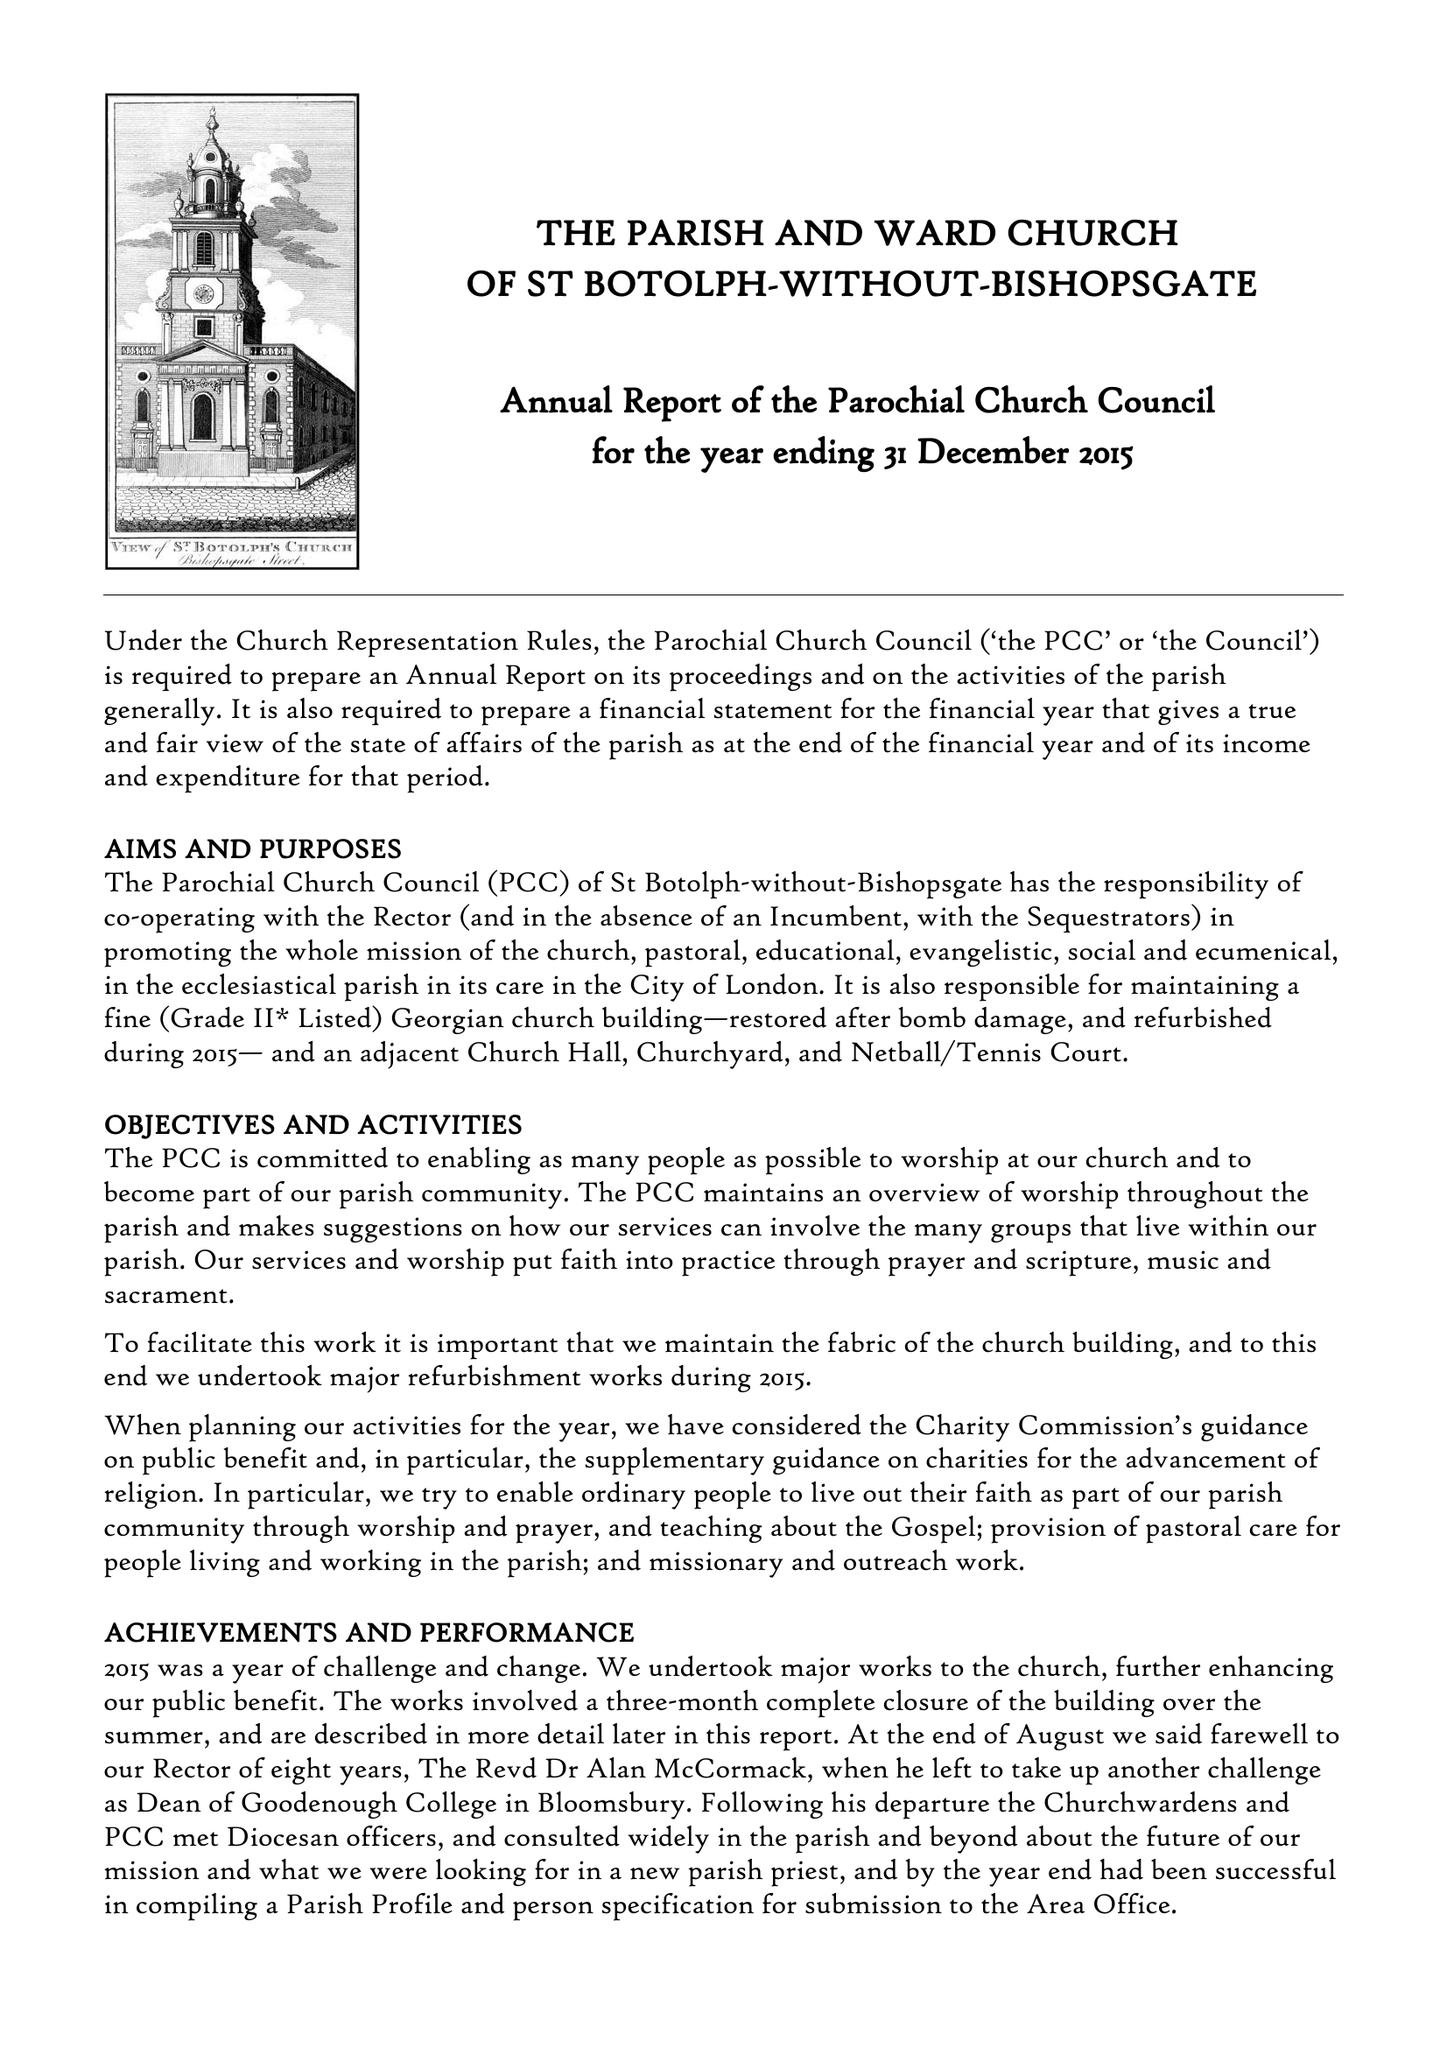What is the value for the report_date?
Answer the question using a single word or phrase. 2015-12-31 